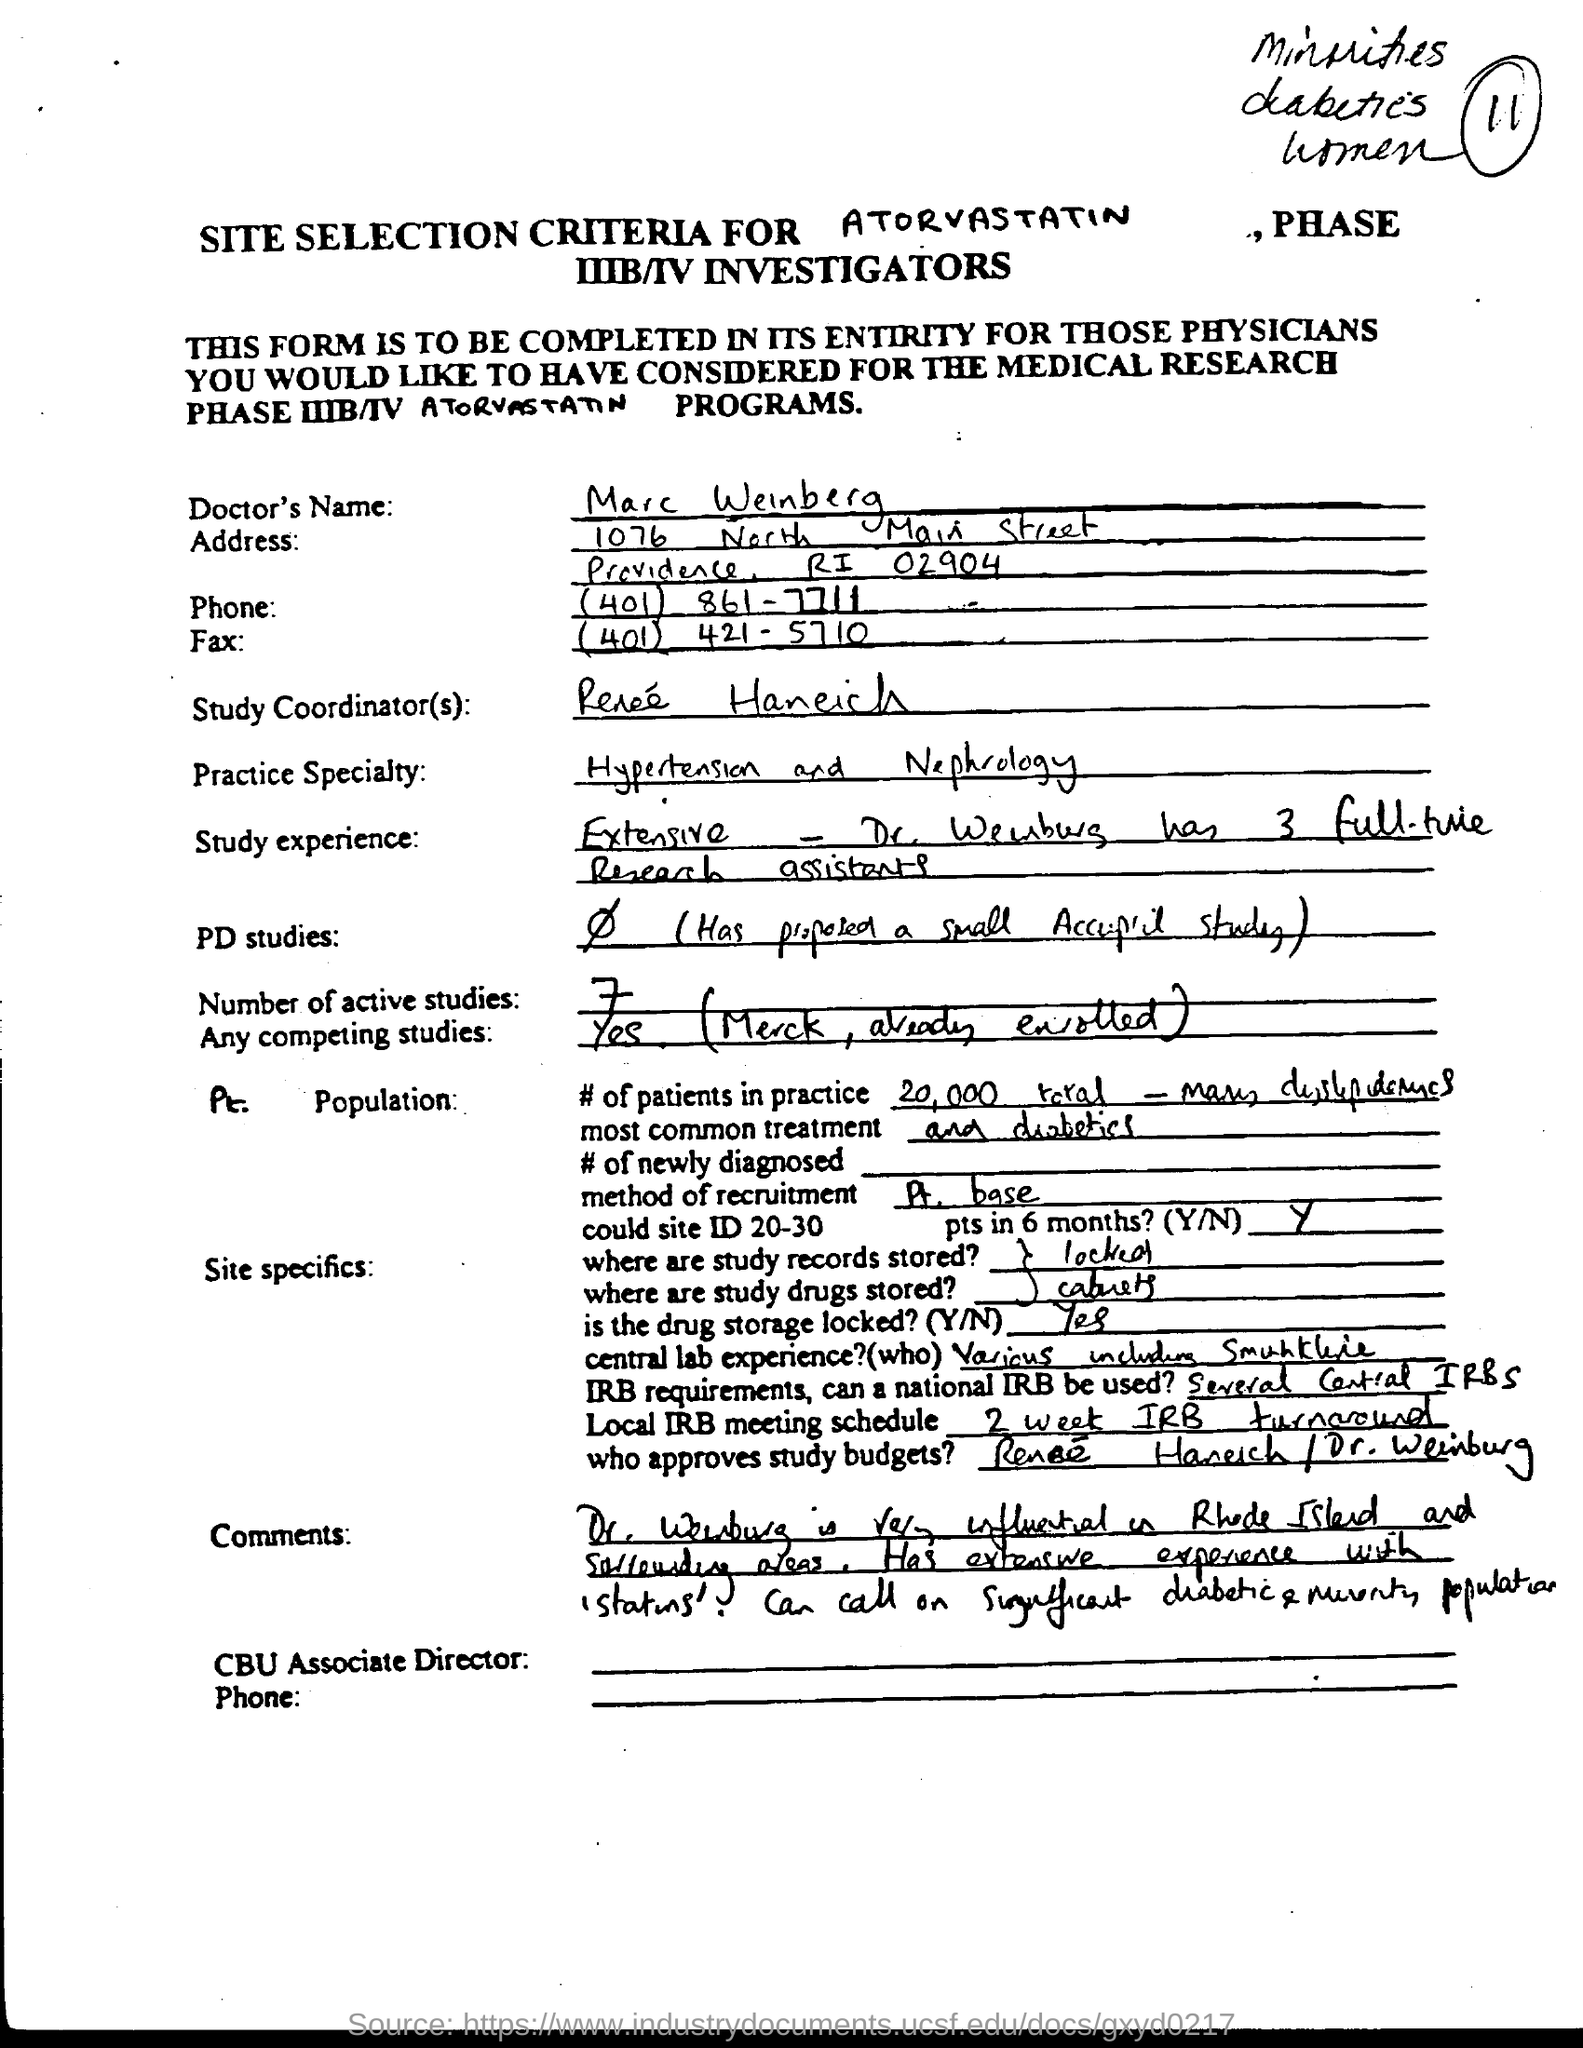Outline some significant characteristics in this image. There are seven active studies. The doctor's practice specialty is hypertension and nephrology, which involves the diagnosis and treatment of high blood pressure and related kidney problems. 